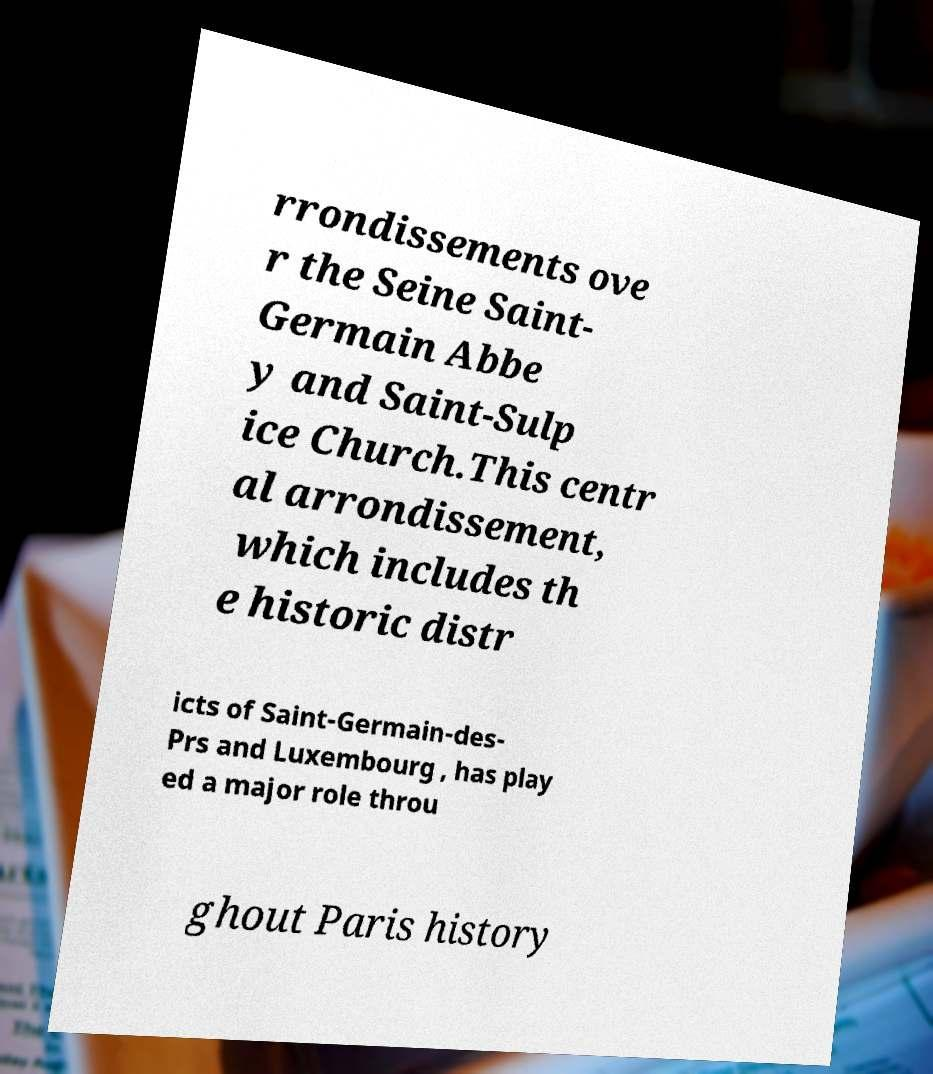Can you accurately transcribe the text from the provided image for me? rrondissements ove r the Seine Saint- Germain Abbe y and Saint-Sulp ice Church.This centr al arrondissement, which includes th e historic distr icts of Saint-Germain-des- Prs and Luxembourg , has play ed a major role throu ghout Paris history 